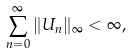Convert formula to latex. <formula><loc_0><loc_0><loc_500><loc_500>\sum _ { n = 0 } ^ { \infty } \| U _ { n } \| _ { \infty } < \infty ,</formula> 